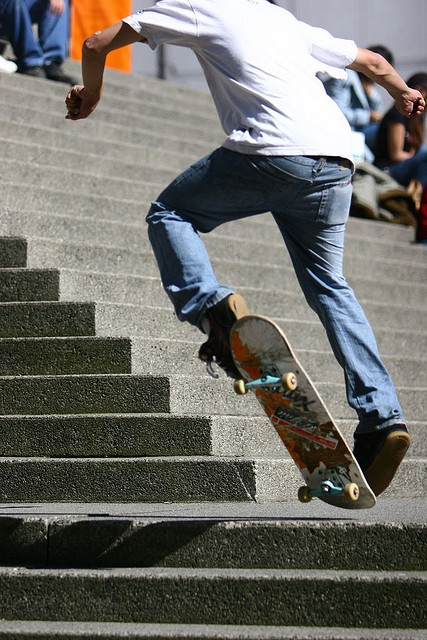Describe the objects in this image and their specific colors. I can see people in black, white, gray, and darkgray tones, skateboard in black, gray, and maroon tones, people in black, gray, navy, and darkblue tones, people in black, darkgray, gray, and lavender tones, and people in black, maroon, navy, and gray tones in this image. 